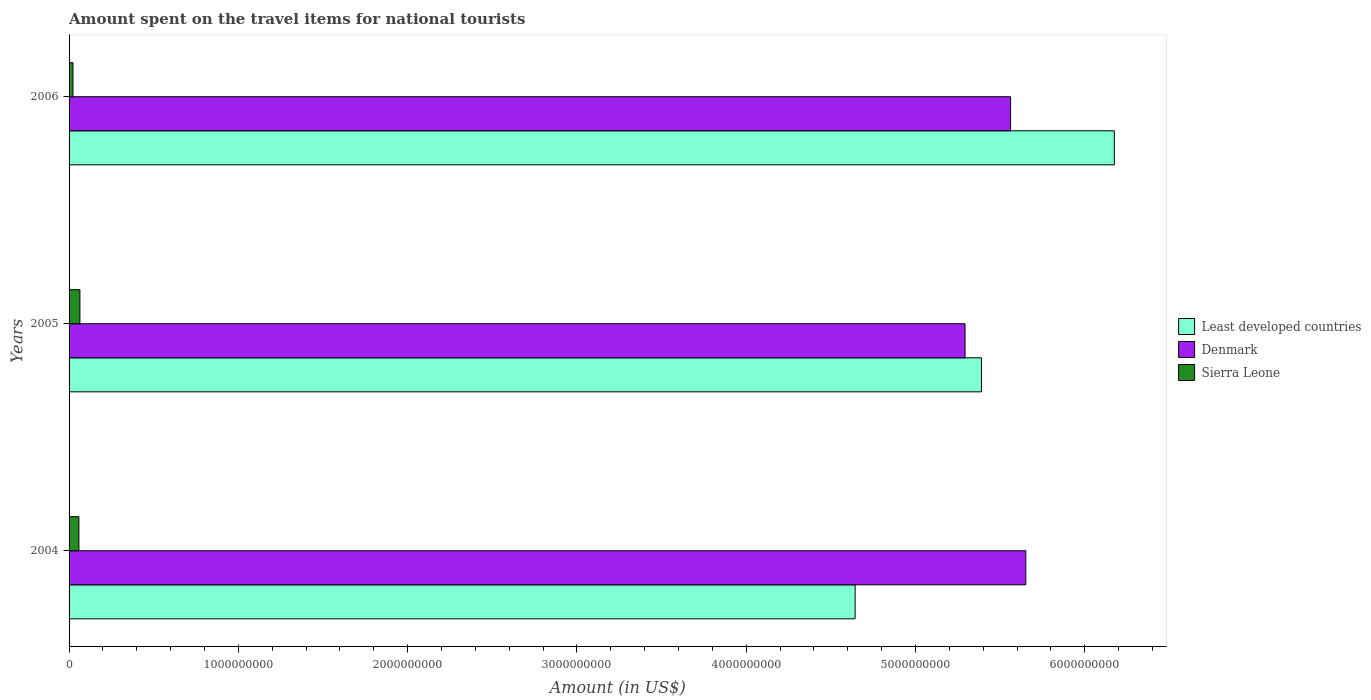How many different coloured bars are there?
Provide a succinct answer. 3. Are the number of bars on each tick of the Y-axis equal?
Give a very brief answer. Yes. How many bars are there on the 1st tick from the top?
Your response must be concise. 3. How many bars are there on the 1st tick from the bottom?
Offer a terse response. 3. In how many cases, is the number of bars for a given year not equal to the number of legend labels?
Give a very brief answer. 0. What is the amount spent on the travel items for national tourists in Least developed countries in 2005?
Provide a short and direct response. 5.39e+09. Across all years, what is the maximum amount spent on the travel items for national tourists in Sierra Leone?
Make the answer very short. 6.40e+07. Across all years, what is the minimum amount spent on the travel items for national tourists in Sierra Leone?
Provide a short and direct response. 2.30e+07. In which year was the amount spent on the travel items for national tourists in Denmark maximum?
Keep it short and to the point. 2004. In which year was the amount spent on the travel items for national tourists in Least developed countries minimum?
Keep it short and to the point. 2004. What is the total amount spent on the travel items for national tourists in Least developed countries in the graph?
Your answer should be compact. 1.62e+1. What is the difference between the amount spent on the travel items for national tourists in Denmark in 2004 and that in 2006?
Make the answer very short. 9.00e+07. What is the difference between the amount spent on the travel items for national tourists in Sierra Leone in 2004 and the amount spent on the travel items for national tourists in Least developed countries in 2005?
Your answer should be very brief. -5.33e+09. What is the average amount spent on the travel items for national tourists in Denmark per year?
Provide a short and direct response. 5.50e+09. In the year 2005, what is the difference between the amount spent on the travel items for national tourists in Denmark and amount spent on the travel items for national tourists in Sierra Leone?
Offer a terse response. 5.23e+09. What is the ratio of the amount spent on the travel items for national tourists in Denmark in 2005 to that in 2006?
Your answer should be very brief. 0.95. Is the amount spent on the travel items for national tourists in Sierra Leone in 2004 less than that in 2006?
Ensure brevity in your answer.  No. Is the difference between the amount spent on the travel items for national tourists in Denmark in 2005 and 2006 greater than the difference between the amount spent on the travel items for national tourists in Sierra Leone in 2005 and 2006?
Make the answer very short. No. What is the difference between the highest and the lowest amount spent on the travel items for national tourists in Least developed countries?
Provide a short and direct response. 1.53e+09. What does the 2nd bar from the top in 2006 represents?
Your answer should be compact. Denmark. What does the 2nd bar from the bottom in 2005 represents?
Your response must be concise. Denmark. Is it the case that in every year, the sum of the amount spent on the travel items for national tourists in Sierra Leone and amount spent on the travel items for national tourists in Least developed countries is greater than the amount spent on the travel items for national tourists in Denmark?
Provide a short and direct response. No. How many bars are there?
Your response must be concise. 9. Are all the bars in the graph horizontal?
Make the answer very short. Yes. Are the values on the major ticks of X-axis written in scientific E-notation?
Your response must be concise. No. Where does the legend appear in the graph?
Your answer should be compact. Center right. How are the legend labels stacked?
Keep it short and to the point. Vertical. What is the title of the graph?
Ensure brevity in your answer.  Amount spent on the travel items for national tourists. Does "Afghanistan" appear as one of the legend labels in the graph?
Provide a succinct answer. No. What is the Amount (in US$) of Least developed countries in 2004?
Keep it short and to the point. 4.64e+09. What is the Amount (in US$) of Denmark in 2004?
Your answer should be very brief. 5.65e+09. What is the Amount (in US$) in Sierra Leone in 2004?
Offer a very short reply. 5.80e+07. What is the Amount (in US$) in Least developed countries in 2005?
Provide a short and direct response. 5.39e+09. What is the Amount (in US$) in Denmark in 2005?
Offer a terse response. 5.29e+09. What is the Amount (in US$) in Sierra Leone in 2005?
Your answer should be compact. 6.40e+07. What is the Amount (in US$) of Least developed countries in 2006?
Your response must be concise. 6.17e+09. What is the Amount (in US$) of Denmark in 2006?
Offer a very short reply. 5.56e+09. What is the Amount (in US$) in Sierra Leone in 2006?
Provide a short and direct response. 2.30e+07. Across all years, what is the maximum Amount (in US$) in Least developed countries?
Your answer should be compact. 6.17e+09. Across all years, what is the maximum Amount (in US$) of Denmark?
Your response must be concise. 5.65e+09. Across all years, what is the maximum Amount (in US$) in Sierra Leone?
Your answer should be very brief. 6.40e+07. Across all years, what is the minimum Amount (in US$) of Least developed countries?
Give a very brief answer. 4.64e+09. Across all years, what is the minimum Amount (in US$) in Denmark?
Give a very brief answer. 5.29e+09. Across all years, what is the minimum Amount (in US$) of Sierra Leone?
Provide a short and direct response. 2.30e+07. What is the total Amount (in US$) in Least developed countries in the graph?
Give a very brief answer. 1.62e+1. What is the total Amount (in US$) in Denmark in the graph?
Make the answer very short. 1.65e+1. What is the total Amount (in US$) of Sierra Leone in the graph?
Give a very brief answer. 1.45e+08. What is the difference between the Amount (in US$) in Least developed countries in 2004 and that in 2005?
Provide a short and direct response. -7.46e+08. What is the difference between the Amount (in US$) of Denmark in 2004 and that in 2005?
Your response must be concise. 3.59e+08. What is the difference between the Amount (in US$) of Sierra Leone in 2004 and that in 2005?
Ensure brevity in your answer.  -6.00e+06. What is the difference between the Amount (in US$) in Least developed countries in 2004 and that in 2006?
Keep it short and to the point. -1.53e+09. What is the difference between the Amount (in US$) of Denmark in 2004 and that in 2006?
Your response must be concise. 9.00e+07. What is the difference between the Amount (in US$) in Sierra Leone in 2004 and that in 2006?
Your answer should be very brief. 3.50e+07. What is the difference between the Amount (in US$) of Least developed countries in 2005 and that in 2006?
Give a very brief answer. -7.85e+08. What is the difference between the Amount (in US$) in Denmark in 2005 and that in 2006?
Keep it short and to the point. -2.69e+08. What is the difference between the Amount (in US$) in Sierra Leone in 2005 and that in 2006?
Keep it short and to the point. 4.10e+07. What is the difference between the Amount (in US$) in Least developed countries in 2004 and the Amount (in US$) in Denmark in 2005?
Provide a succinct answer. -6.49e+08. What is the difference between the Amount (in US$) of Least developed countries in 2004 and the Amount (in US$) of Sierra Leone in 2005?
Ensure brevity in your answer.  4.58e+09. What is the difference between the Amount (in US$) of Denmark in 2004 and the Amount (in US$) of Sierra Leone in 2005?
Give a very brief answer. 5.59e+09. What is the difference between the Amount (in US$) in Least developed countries in 2004 and the Amount (in US$) in Denmark in 2006?
Your response must be concise. -9.18e+08. What is the difference between the Amount (in US$) of Least developed countries in 2004 and the Amount (in US$) of Sierra Leone in 2006?
Ensure brevity in your answer.  4.62e+09. What is the difference between the Amount (in US$) of Denmark in 2004 and the Amount (in US$) of Sierra Leone in 2006?
Ensure brevity in your answer.  5.63e+09. What is the difference between the Amount (in US$) in Least developed countries in 2005 and the Amount (in US$) in Denmark in 2006?
Keep it short and to the point. -1.72e+08. What is the difference between the Amount (in US$) of Least developed countries in 2005 and the Amount (in US$) of Sierra Leone in 2006?
Offer a terse response. 5.37e+09. What is the difference between the Amount (in US$) of Denmark in 2005 and the Amount (in US$) of Sierra Leone in 2006?
Ensure brevity in your answer.  5.27e+09. What is the average Amount (in US$) in Least developed countries per year?
Your answer should be very brief. 5.40e+09. What is the average Amount (in US$) of Denmark per year?
Offer a very short reply. 5.50e+09. What is the average Amount (in US$) of Sierra Leone per year?
Offer a terse response. 4.83e+07. In the year 2004, what is the difference between the Amount (in US$) in Least developed countries and Amount (in US$) in Denmark?
Your answer should be compact. -1.01e+09. In the year 2004, what is the difference between the Amount (in US$) in Least developed countries and Amount (in US$) in Sierra Leone?
Offer a very short reply. 4.59e+09. In the year 2004, what is the difference between the Amount (in US$) in Denmark and Amount (in US$) in Sierra Leone?
Your answer should be compact. 5.59e+09. In the year 2005, what is the difference between the Amount (in US$) in Least developed countries and Amount (in US$) in Denmark?
Ensure brevity in your answer.  9.70e+07. In the year 2005, what is the difference between the Amount (in US$) of Least developed countries and Amount (in US$) of Sierra Leone?
Ensure brevity in your answer.  5.33e+09. In the year 2005, what is the difference between the Amount (in US$) in Denmark and Amount (in US$) in Sierra Leone?
Offer a very short reply. 5.23e+09. In the year 2006, what is the difference between the Amount (in US$) of Least developed countries and Amount (in US$) of Denmark?
Offer a very short reply. 6.13e+08. In the year 2006, what is the difference between the Amount (in US$) in Least developed countries and Amount (in US$) in Sierra Leone?
Your answer should be very brief. 6.15e+09. In the year 2006, what is the difference between the Amount (in US$) in Denmark and Amount (in US$) in Sierra Leone?
Offer a terse response. 5.54e+09. What is the ratio of the Amount (in US$) in Least developed countries in 2004 to that in 2005?
Ensure brevity in your answer.  0.86. What is the ratio of the Amount (in US$) of Denmark in 2004 to that in 2005?
Your answer should be compact. 1.07. What is the ratio of the Amount (in US$) of Sierra Leone in 2004 to that in 2005?
Make the answer very short. 0.91. What is the ratio of the Amount (in US$) of Least developed countries in 2004 to that in 2006?
Your response must be concise. 0.75. What is the ratio of the Amount (in US$) in Denmark in 2004 to that in 2006?
Your answer should be very brief. 1.02. What is the ratio of the Amount (in US$) of Sierra Leone in 2004 to that in 2006?
Provide a short and direct response. 2.52. What is the ratio of the Amount (in US$) in Least developed countries in 2005 to that in 2006?
Ensure brevity in your answer.  0.87. What is the ratio of the Amount (in US$) in Denmark in 2005 to that in 2006?
Provide a short and direct response. 0.95. What is the ratio of the Amount (in US$) of Sierra Leone in 2005 to that in 2006?
Your answer should be compact. 2.78. What is the difference between the highest and the second highest Amount (in US$) of Least developed countries?
Provide a succinct answer. 7.85e+08. What is the difference between the highest and the second highest Amount (in US$) of Denmark?
Keep it short and to the point. 9.00e+07. What is the difference between the highest and the second highest Amount (in US$) in Sierra Leone?
Offer a terse response. 6.00e+06. What is the difference between the highest and the lowest Amount (in US$) in Least developed countries?
Provide a succinct answer. 1.53e+09. What is the difference between the highest and the lowest Amount (in US$) of Denmark?
Provide a succinct answer. 3.59e+08. What is the difference between the highest and the lowest Amount (in US$) of Sierra Leone?
Offer a terse response. 4.10e+07. 